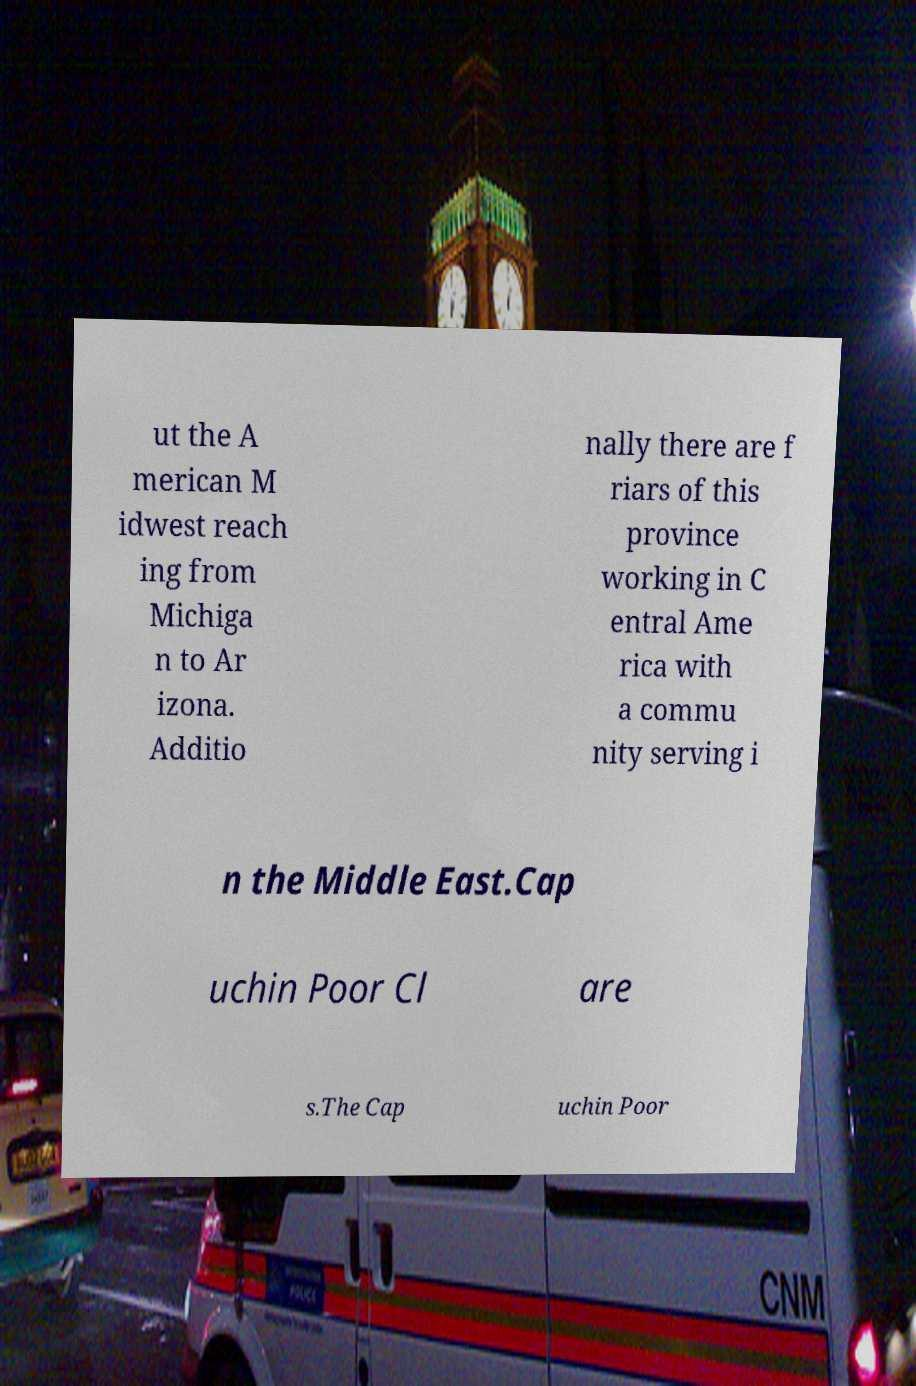For documentation purposes, I need the text within this image transcribed. Could you provide that? ut the A merican M idwest reach ing from Michiga n to Ar izona. Additio nally there are f riars of this province working in C entral Ame rica with a commu nity serving i n the Middle East.Cap uchin Poor Cl are s.The Cap uchin Poor 